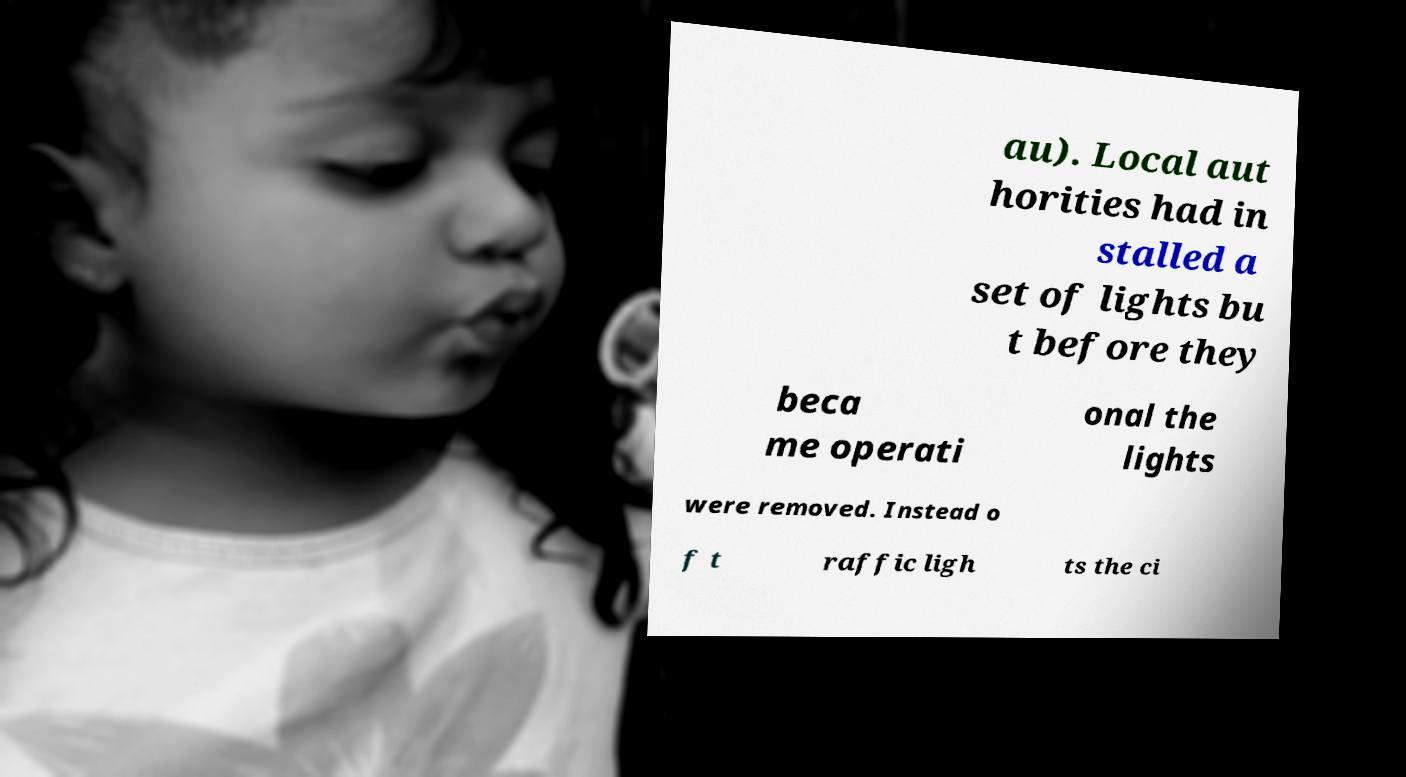Can you read and provide the text displayed in the image?This photo seems to have some interesting text. Can you extract and type it out for me? au). Local aut horities had in stalled a set of lights bu t before they beca me operati onal the lights were removed. Instead o f t raffic ligh ts the ci 